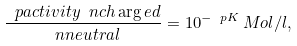<formula> <loc_0><loc_0><loc_500><loc_500>\frac { \ p a c t i v i t y \ n c h \arg e d } { \ n n e u t r a l } = 1 0 ^ { - \ p K } \, M o l / l ,</formula> 